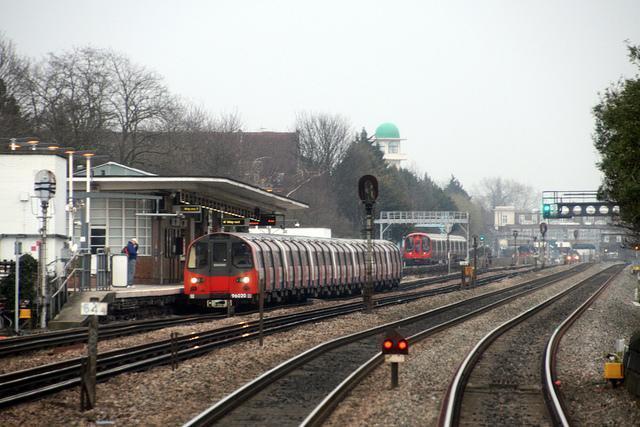How many trains are visible?
Give a very brief answer. 2. 